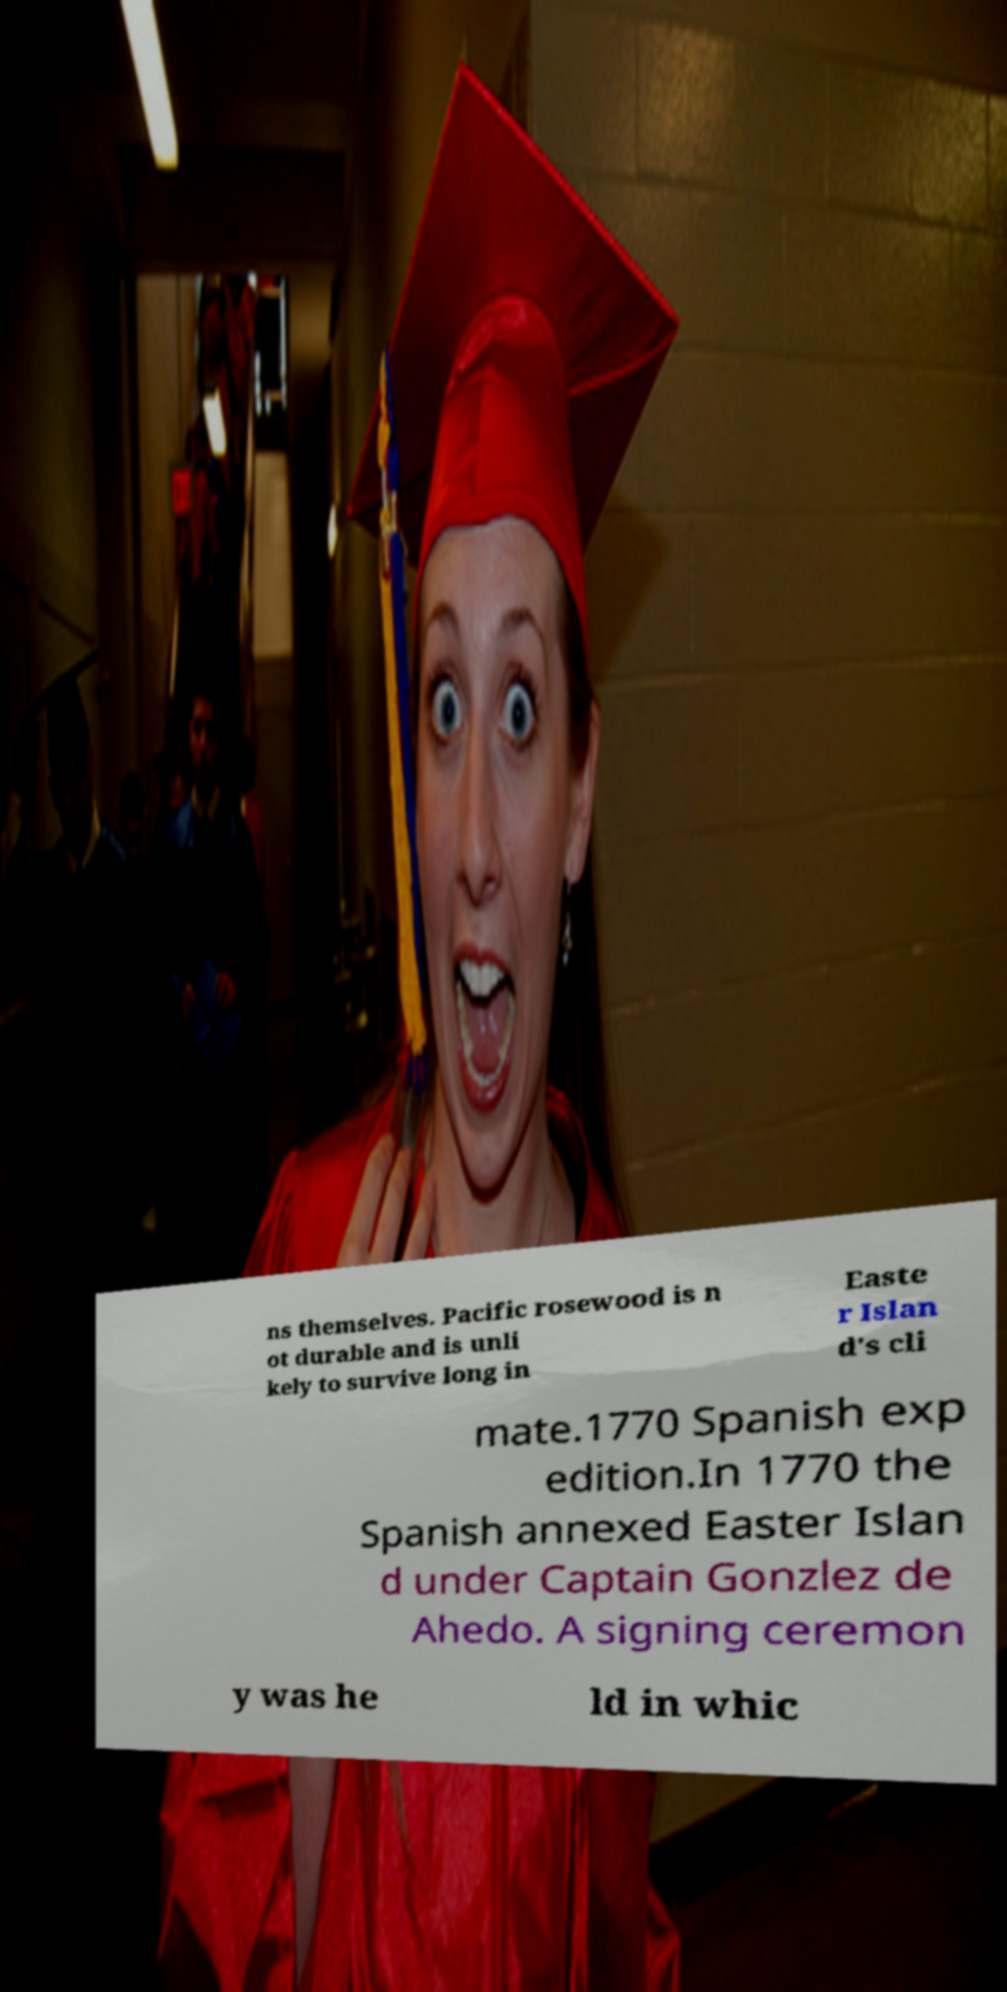Please read and relay the text visible in this image. What does it say? ns themselves. Pacific rosewood is n ot durable and is unli kely to survive long in Easte r Islan d's cli mate.1770 Spanish exp edition.In 1770 the Spanish annexed Easter Islan d under Captain Gonzlez de Ahedo. A signing ceremon y was he ld in whic 